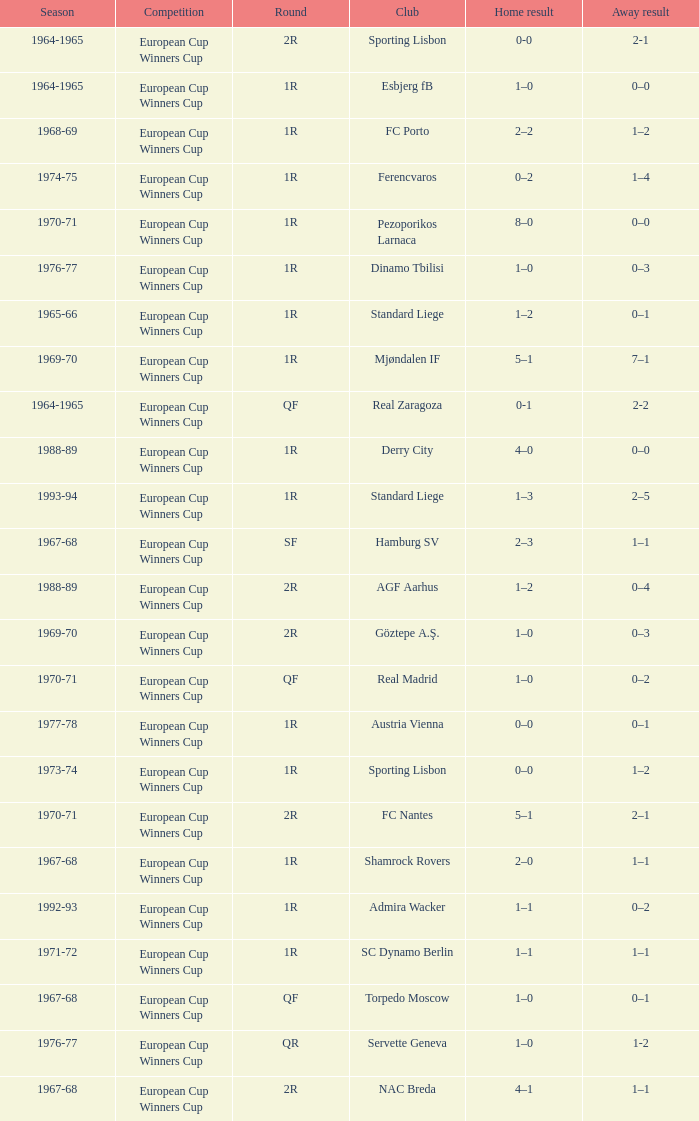Home result of 1–0, and a Away result of 0–1 involves what club? Torpedo Moscow. 